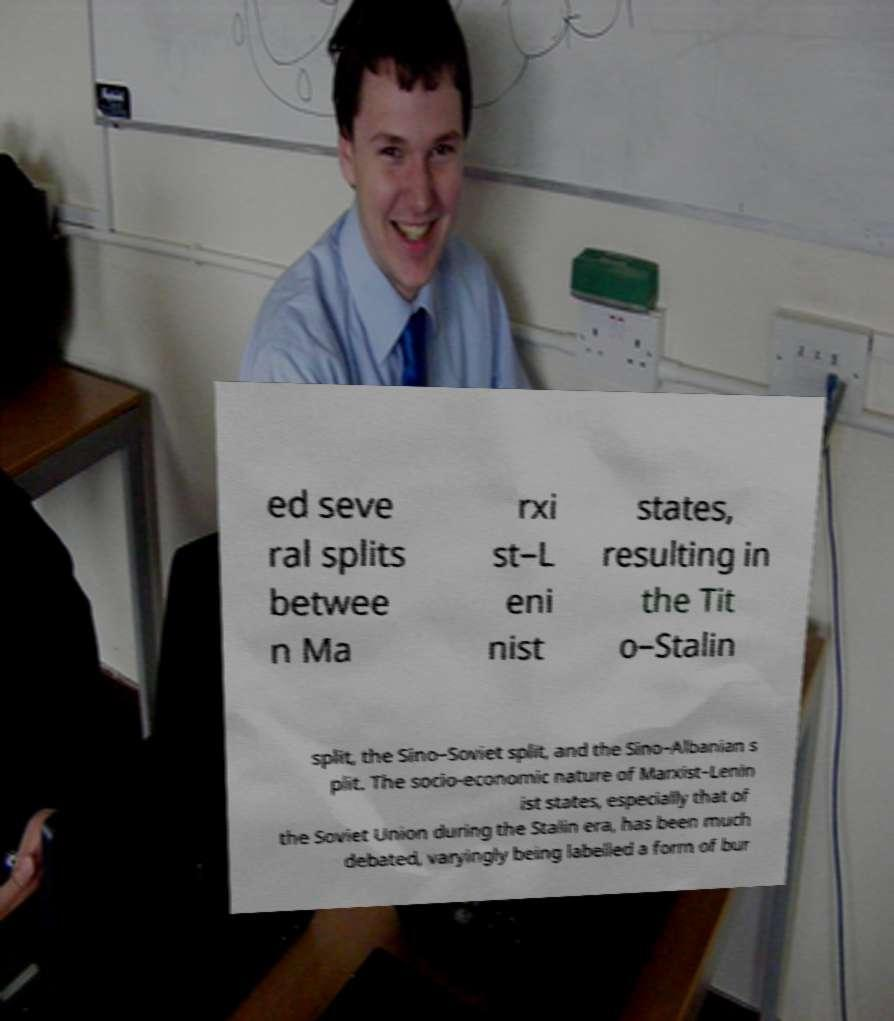There's text embedded in this image that I need extracted. Can you transcribe it verbatim? ed seve ral splits betwee n Ma rxi st–L eni nist states, resulting in the Tit o–Stalin split, the Sino–Soviet split, and the Sino–Albanian s plit. The socio-economic nature of Marxist–Lenin ist states, especially that of the Soviet Union during the Stalin era, has been much debated, varyingly being labelled a form of bur 